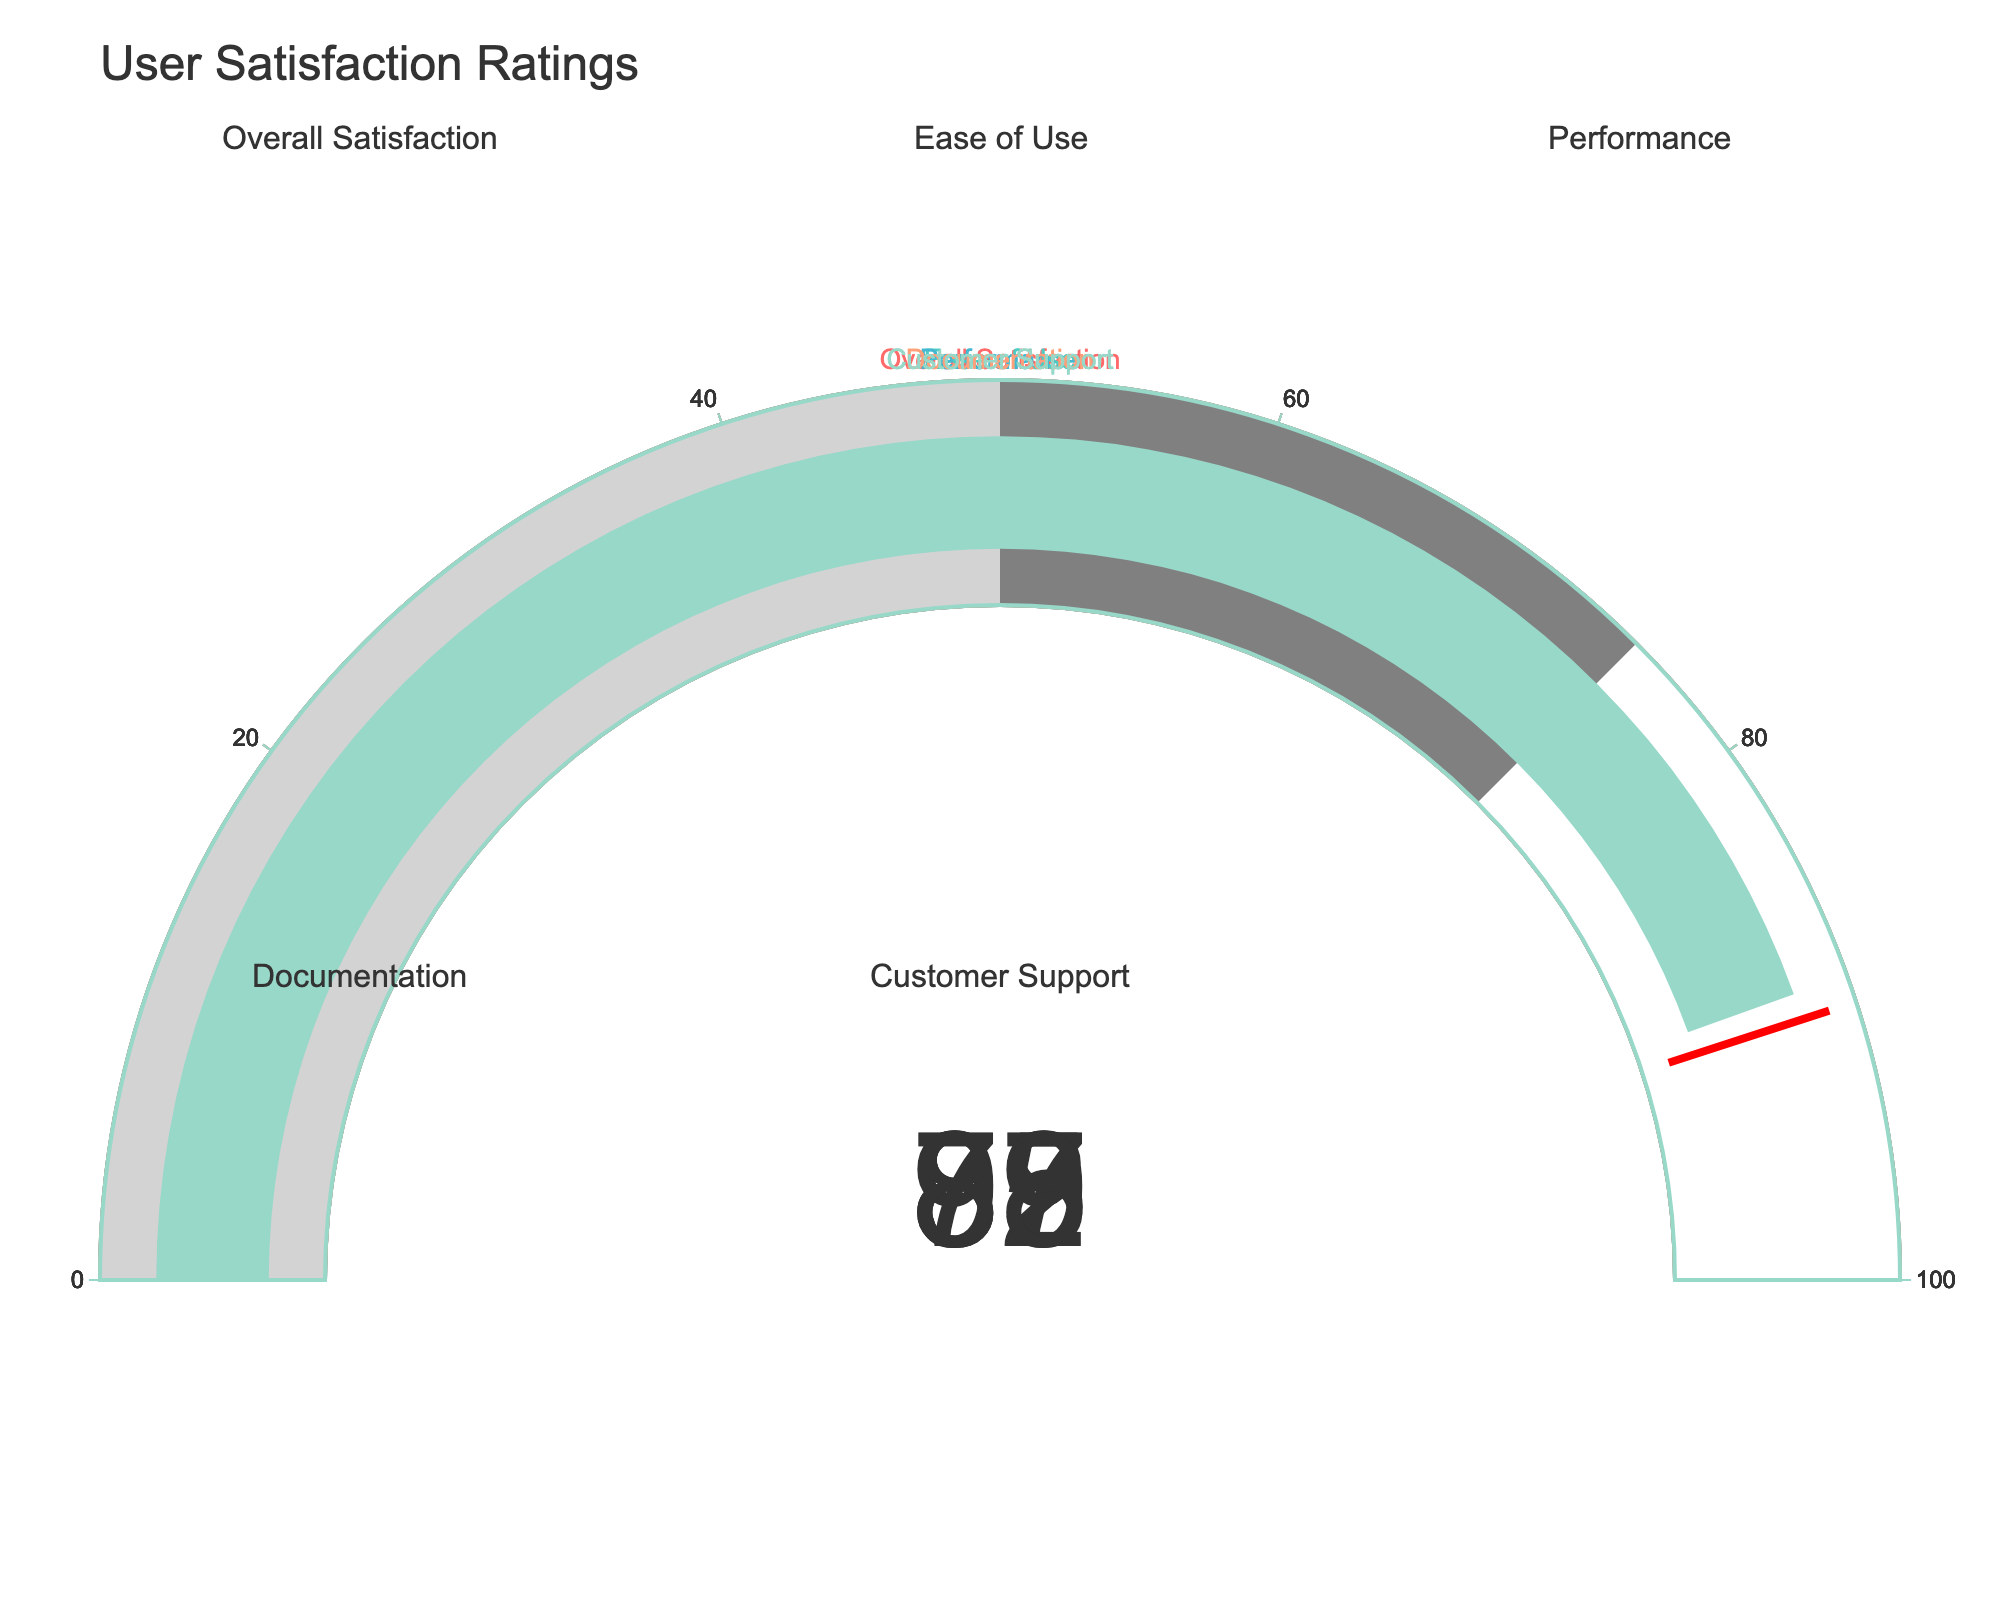What is the highest user satisfaction rating? By looking at the gauge with the highest value, we identify "Ease of Use" with a rating of 92.
Answer: 92 Which aspect has the lowest user satisfaction rating? By looking at the gauge with the lowest value, we identify "Documentation" with a rating of 78.
Answer: Documentation How many aspects have a satisfaction rating above 85? "Overall Satisfaction" (87), "Ease of Use" (92), "Performance" (85), and "Customer Support" (89). Thus, 4 aspects have ratings above 85.
Answer: 4 What is the average satisfaction rating for all the aspects? Sum all the values (87 + 92 + 85 + 78 + 89) and divide by the number of aspects (5). The sum is 431, and dividing by 5 gives an average rating of 86.2.
Answer: 86.2 How does the user satisfaction rating for "Documentation" compare to "Customer Support"? "Documentation" has a rating of 78, whereas "Customer Support" has a rating of 89. "Customer Support" is 11 points higher than "Documentation."
Answer: Customer Support is 11 points higher What is the range of user satisfaction ratings across all aspects? The highest rating is 92 ("Ease of Use") and the lowest is 78 ("Documentation"). The range is 92 - 78 = 14.
Answer: 14 Which aspect is closest to the threshold of 90 that is marked on the gauges? The value closest to the threshold is 89 for "Customer Support," being only 1 point away from 90.
Answer: Customer Support Are there any aspects with a satisfaction rating equal to or above the threshold level of 90? "Ease of Use" has a satisfaction rating equal to 92, which is above the threshold of 90.
Answer: Yes, one (Ease of Use) What is the difference between the highest and the second-highest user satisfaction ratings? The highest rating is 92 for "Ease of Use," and the second-highest is 89 for "Customer Support." The difference is 92 - 89 = 3.
Answer: 3 Which aspects have satisfaction ratings in the range of 80 to 90? "Overall Satisfaction" (87), "Performance" (85), and "Customer Support" (89) all have ratings between 80 and 90.
Answer: Overall Satisfaction, Performance, Customer Support 